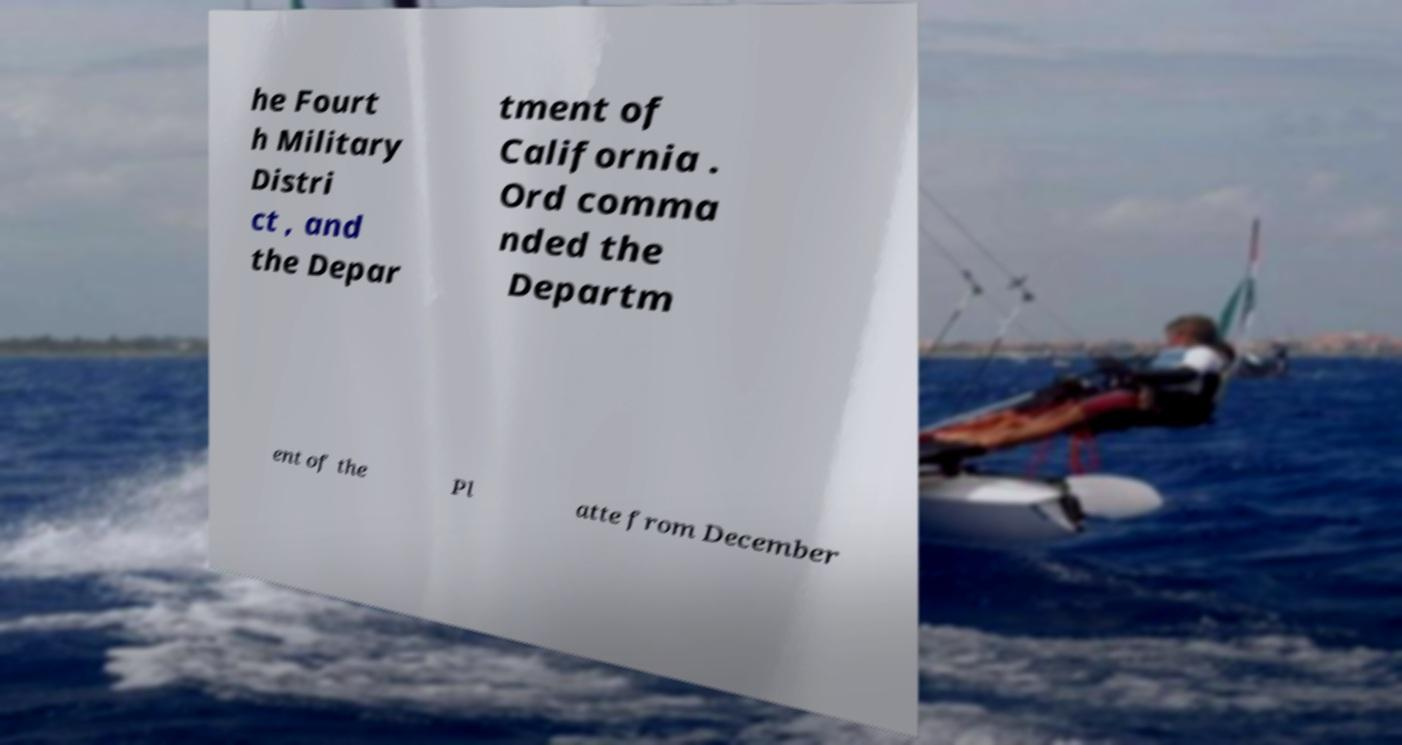Could you assist in decoding the text presented in this image and type it out clearly? he Fourt h Military Distri ct , and the Depar tment of California . Ord comma nded the Departm ent of the Pl atte from December 